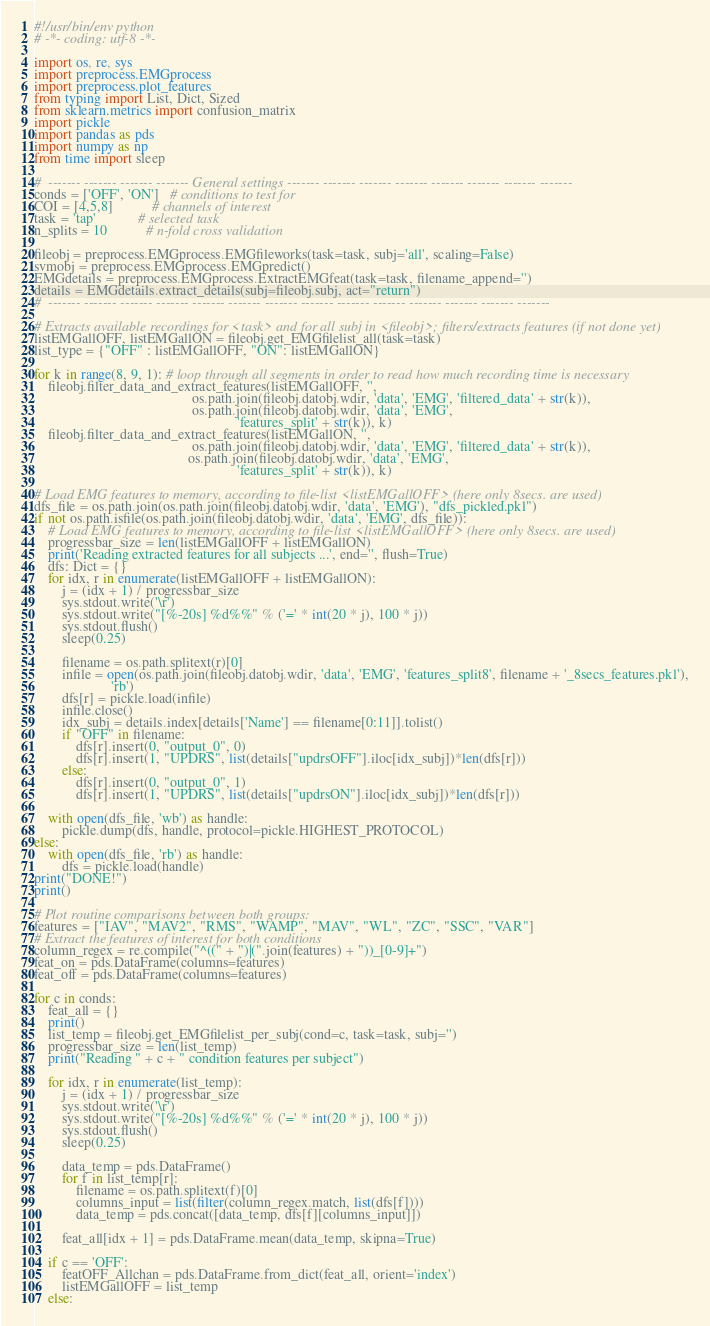<code> <loc_0><loc_0><loc_500><loc_500><_Python_>#!/usr/bin/env python
# -*- coding: utf-8 -*-

import os, re, sys
import preprocess.EMGprocess
import preprocess.plot_features
from typing import List, Dict, Sized
from sklearn.metrics import confusion_matrix
import pickle
import pandas as pds
import numpy as np
from time import sleep

#  ------- ------- ------- ------- General settings ------- ------- ------- ------- ------- ------- ------- -------
conds = ['OFF', 'ON']   # conditions to test for
COI = [4,5,8]           # channels of interest
task = 'tap'            # selected task
n_splits = 10           # n-fold cross validation

fileobj = preprocess.EMGprocess.EMGfileworks(task=task, subj='all', scaling=False)
svmobj = preprocess.EMGprocess.EMGpredict()
EMGdetails = preprocess.EMGprocess.ExtractEMGfeat(task=task, filename_append='')
details = EMGdetails.extract_details(subj=fileobj.subj, act="return")
#  ------- ------- ------- ------- ------- ------- ------- ------- ------- ------- ------- ------- ------- -------

# Extracts available recordings for <task> and for all subj in <fileobj>; filters/extracts features (if not done yet)
listEMGallOFF, listEMGallON = fileobj.get_EMGfilelist_all(task=task)
list_type = {"OFF" : listEMGallOFF, "ON": listEMGallON}

for k in range(8, 9, 1): # loop through all segments in order to read how much recording time is necessary
    fileobj.filter_data_and_extract_features(listEMGallOFF, '',
                                             os.path.join(fileobj.datobj.wdir, 'data', 'EMG', 'filtered_data' + str(k)),
                                             os.path.join(fileobj.datobj.wdir, 'data', 'EMG',
                                                          'features_split' + str(k)), k)
    fileobj.filter_data_and_extract_features(listEMGallON, '',
                                             os.path.join(fileobj.datobj.wdir, 'data', 'EMG', 'filtered_data' + str(k)),
                                            os.path.join(fileobj.datobj.wdir, 'data', 'EMG',
                                                          'features_split' + str(k)), k)

# Load EMG features to memory, according to file-list <listEMGallOFF> (here only 8secs. are used)
dfs_file = os.path.join(os.path.join(fileobj.datobj.wdir, 'data', 'EMG'), "dfs_pickled.pkl")
if not os.path.isfile(os.path.join(fileobj.datobj.wdir, 'data', 'EMG', dfs_file)):
    # Load EMG features to memory, according to file-list <listEMGallOFF> (here only 8secs. are used)
    progressbar_size = len(listEMGallOFF + listEMGallON)
    print('Reading extracted features for all subjects ...', end='', flush=True)
    dfs: Dict = {}
    for idx, r in enumerate(listEMGallOFF + listEMGallON):
        j = (idx + 1) / progressbar_size
        sys.stdout.write('\r')
        sys.stdout.write("[%-20s] %d%%" % ('=' * int(20 * j), 100 * j))
        sys.stdout.flush()
        sleep(0.25)

        filename = os.path.splitext(r)[0]
        infile = open(os.path.join(fileobj.datobj.wdir, 'data', 'EMG', 'features_split8', filename + '_8secs_features.pkl'),
                      'rb')
        dfs[r] = pickle.load(infile)
        infile.close()
        idx_subj = details.index[details['Name'] == filename[0:11]].tolist()
        if "OFF" in filename:
            dfs[r].insert(0, "output_0", 0)
            dfs[r].insert(1, "UPDRS", list(details["updrsOFF"].iloc[idx_subj])*len(dfs[r]))
        else:
            dfs[r].insert(0, "output_0", 1)
            dfs[r].insert(1, "UPDRS", list(details["updrsON"].iloc[idx_subj])*len(dfs[r]))

    with open(dfs_file, 'wb') as handle:
        pickle.dump(dfs, handle, protocol=pickle.HIGHEST_PROTOCOL)
else:
    with open(dfs_file, 'rb') as handle:
        dfs = pickle.load(handle)
print("DONE!")
print()

# Plot routine comparisons between both groups:
features = ["IAV", "MAV2", "RMS", "WAMP", "MAV", "WL", "ZC", "SSC", "VAR"]
# Extract the features of interest for both conditions
column_regex = re.compile("^((" + ")|(".join(features) + "))_[0-9]+")
feat_on = pds.DataFrame(columns=features)
feat_off = pds.DataFrame(columns=features)

for c in conds:
    feat_all = {}
    print()
    list_temp = fileobj.get_EMGfilelist_per_subj(cond=c, task=task, subj='')
    progressbar_size = len(list_temp)
    print("Reading " + c + " condition features per subject")

    for idx, r in enumerate(list_temp):
        j = (idx + 1) / progressbar_size
        sys.stdout.write('\r')
        sys.stdout.write("[%-20s] %d%%" % ('=' * int(20 * j), 100 * j))
        sys.stdout.flush()
        sleep(0.25)

        data_temp = pds.DataFrame()
        for f in list_temp[r]:
            filename = os.path.splitext(f)[0]
            columns_input = list(filter(column_regex.match, list(dfs[f])))
            data_temp = pds.concat([data_temp, dfs[f][columns_input]])

        feat_all[idx + 1] = pds.DataFrame.mean(data_temp, skipna=True)

    if c == 'OFF':
        featOFF_Allchan = pds.DataFrame.from_dict(feat_all, orient='index')
        listEMGallOFF = list_temp
    else:</code> 